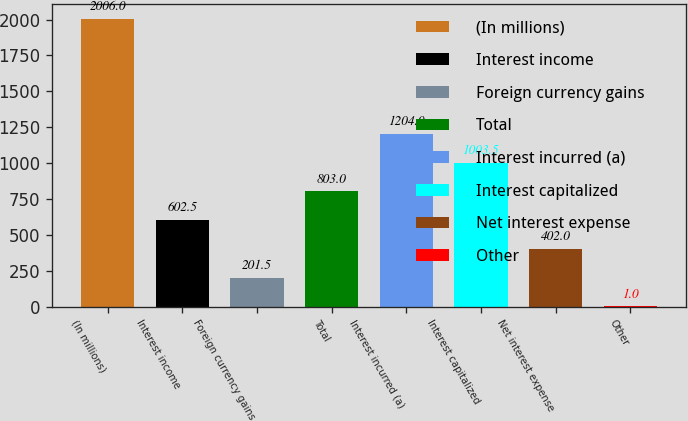Convert chart to OTSL. <chart><loc_0><loc_0><loc_500><loc_500><bar_chart><fcel>(In millions)<fcel>Interest income<fcel>Foreign currency gains<fcel>Total<fcel>Interest incurred (a)<fcel>Interest capitalized<fcel>Net interest expense<fcel>Other<nl><fcel>2006<fcel>602.5<fcel>201.5<fcel>803<fcel>1204<fcel>1003.5<fcel>402<fcel>1<nl></chart> 